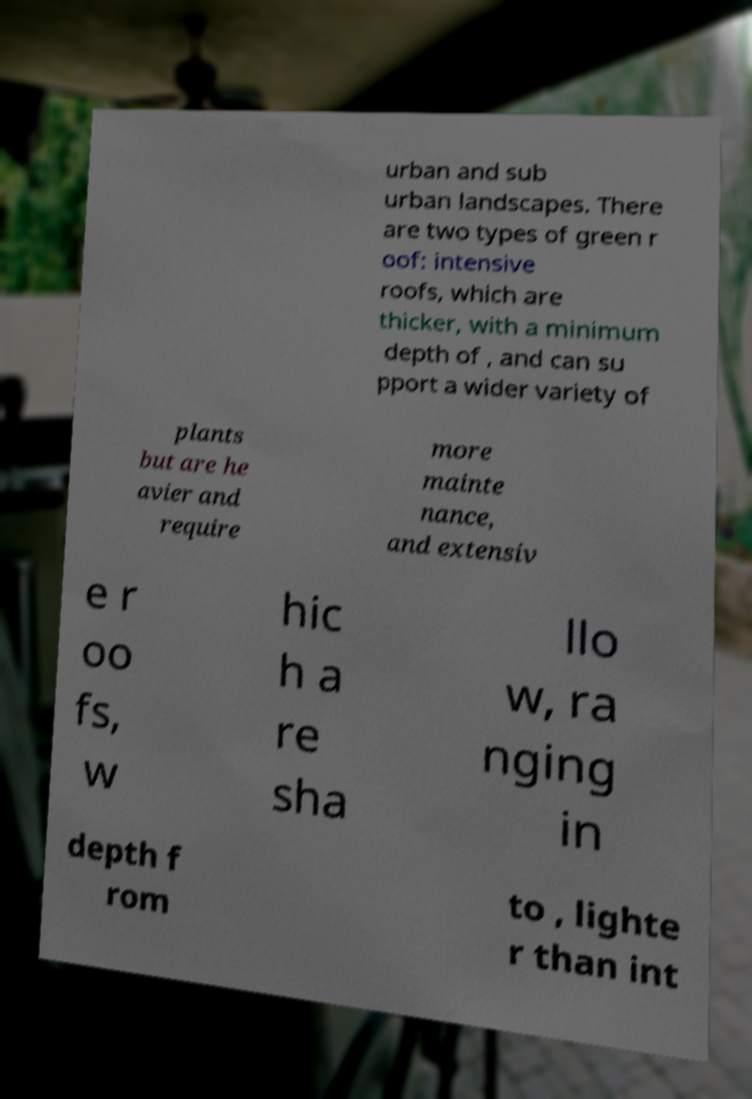Can you read and provide the text displayed in the image?This photo seems to have some interesting text. Can you extract and type it out for me? urban and sub urban landscapes. There are two types of green r oof: intensive roofs, which are thicker, with a minimum depth of , and can su pport a wider variety of plants but are he avier and require more mainte nance, and extensiv e r oo fs, w hic h a re sha llo w, ra nging in depth f rom to , lighte r than int 